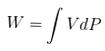Convert formula to latex. <formula><loc_0><loc_0><loc_500><loc_500>W = \int V d P</formula> 